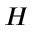<formula> <loc_0><loc_0><loc_500><loc_500>H</formula> 